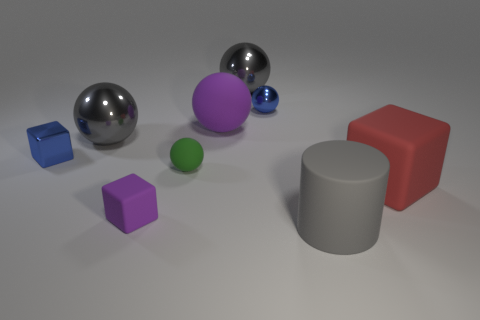What shape is the object that is the same color as the tiny shiny block?
Give a very brief answer. Sphere. What shape is the large thing on the left side of the big matte thing behind the small metallic object in front of the blue shiny ball?
Provide a succinct answer. Sphere. What is the shape of the thing that is both left of the blue shiny sphere and behind the big purple matte object?
Your answer should be very brief. Sphere. Is there a yellow rubber thing of the same size as the green rubber object?
Provide a succinct answer. No. Do the big thing on the left side of the purple block and the large red matte object have the same shape?
Your answer should be compact. No. Is the shape of the tiny green thing the same as the big purple object?
Your answer should be compact. Yes. Are there any large purple things of the same shape as the large red rubber thing?
Keep it short and to the point. No. There is a big matte thing in front of the large thing to the right of the cylinder; what shape is it?
Keep it short and to the point. Cylinder. What is the color of the large matte object that is to the left of the big gray matte cylinder?
Give a very brief answer. Purple. There is a gray object that is made of the same material as the small green thing; what size is it?
Give a very brief answer. Large. 